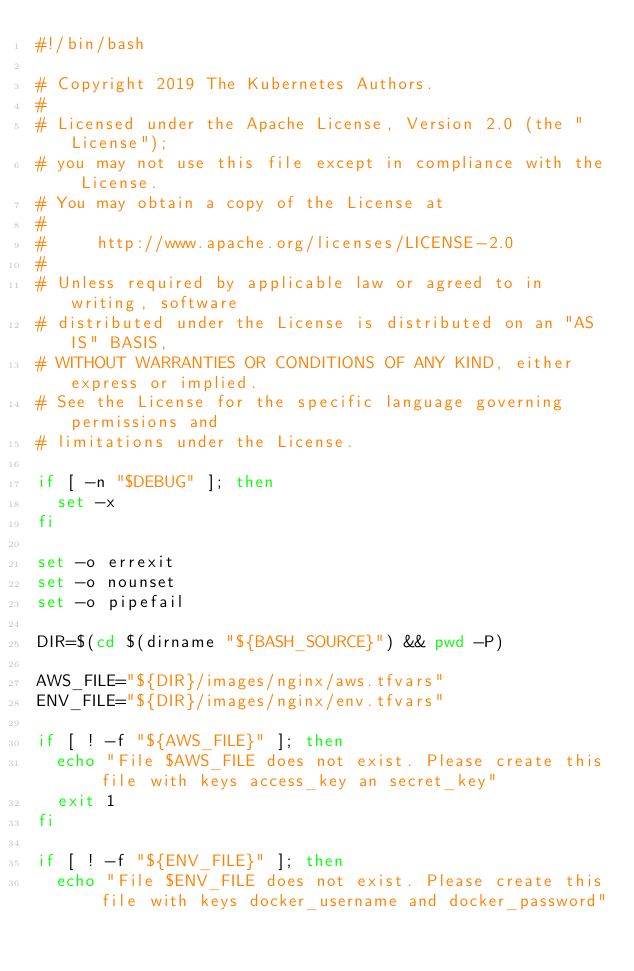Convert code to text. <code><loc_0><loc_0><loc_500><loc_500><_Bash_>#!/bin/bash

# Copyright 2019 The Kubernetes Authors.
#
# Licensed under the Apache License, Version 2.0 (the "License");
# you may not use this file except in compliance with the License.
# You may obtain a copy of the License at
#
#     http://www.apache.org/licenses/LICENSE-2.0
#
# Unless required by applicable law or agreed to in writing, software
# distributed under the License is distributed on an "AS IS" BASIS,
# WITHOUT WARRANTIES OR CONDITIONS OF ANY KIND, either express or implied.
# See the License for the specific language governing permissions and
# limitations under the License.

if [ -n "$DEBUG" ]; then
	set -x
fi

set -o errexit
set -o nounset
set -o pipefail

DIR=$(cd $(dirname "${BASH_SOURCE}") && pwd -P)

AWS_FILE="${DIR}/images/nginx/aws.tfvars"
ENV_FILE="${DIR}/images/nginx/env.tfvars"

if [ ! -f "${AWS_FILE}" ]; then
  echo "File $AWS_FILE does not exist. Please create this file with keys access_key an secret_key"
  exit 1
fi

if [ ! -f "${ENV_FILE}" ]; then
  echo "File $ENV_FILE does not exist. Please create this file with keys docker_username and docker_password"</code> 